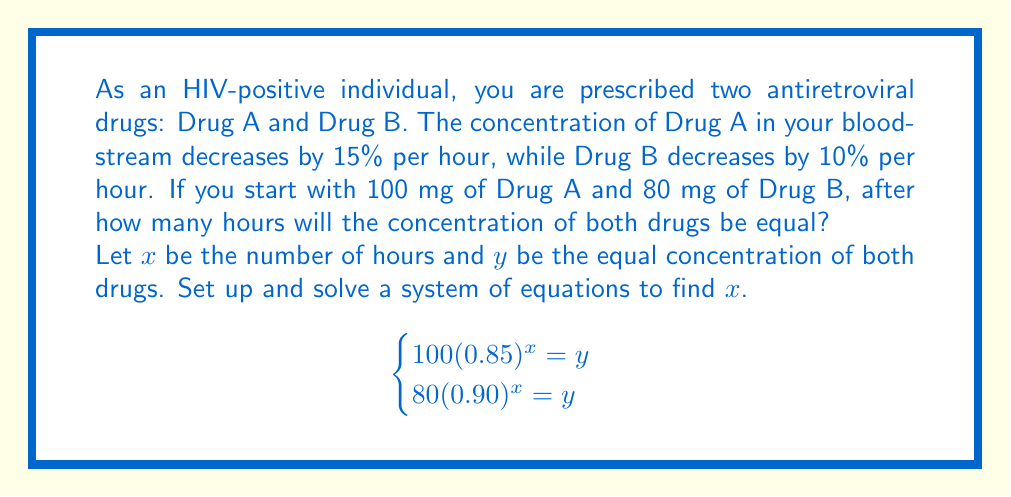Show me your answer to this math problem. Let's solve this system of equations step by step:

1) We have two equations:
   $$100(0.85)^x = y$$
   $$80(0.90)^x = y$$

2) Since both equations equal $y$, we can set them equal to each other:
   $$100(0.85)^x = 80(0.90)^x$$

3) Divide both sides by 80:
   $$1.25(0.85)^x = (0.90)^x$$

4) Take the natural log of both sides:
   $$\ln(1.25) + x\ln(0.85) = x\ln(0.90)$$

5) Subtract $x\ln(0.90)$ from both sides:
   $$\ln(1.25) + x\ln(0.85) - x\ln(0.90) = 0$$

6) Factor out $x$:
   $$\ln(1.25) + x(\ln(0.85) - \ln(0.90)) = 0$$

7) Subtract $\ln(1.25)$ from both sides:
   $$x(\ln(0.85) - \ln(0.90)) = -\ln(1.25)$$

8) Divide both sides by $(\ln(0.85) - \ln(0.90))$:
   $$x = \frac{-\ln(1.25)}{\ln(0.85) - \ln(0.90)}$$

9) Calculate the result:
   $$x \approx 8.2693$$

10) Since time must be a whole number of hours, we round to the nearest hour:
    $$x = 8$$

11) To verify, we can plug this back into our original equations:
    $$100(0.85)^8 \approx 27.2328$$
    $$80(0.90)^8 \approx 27.2184$$

These are approximately equal, confirming our solution.
Answer: 8 hours 